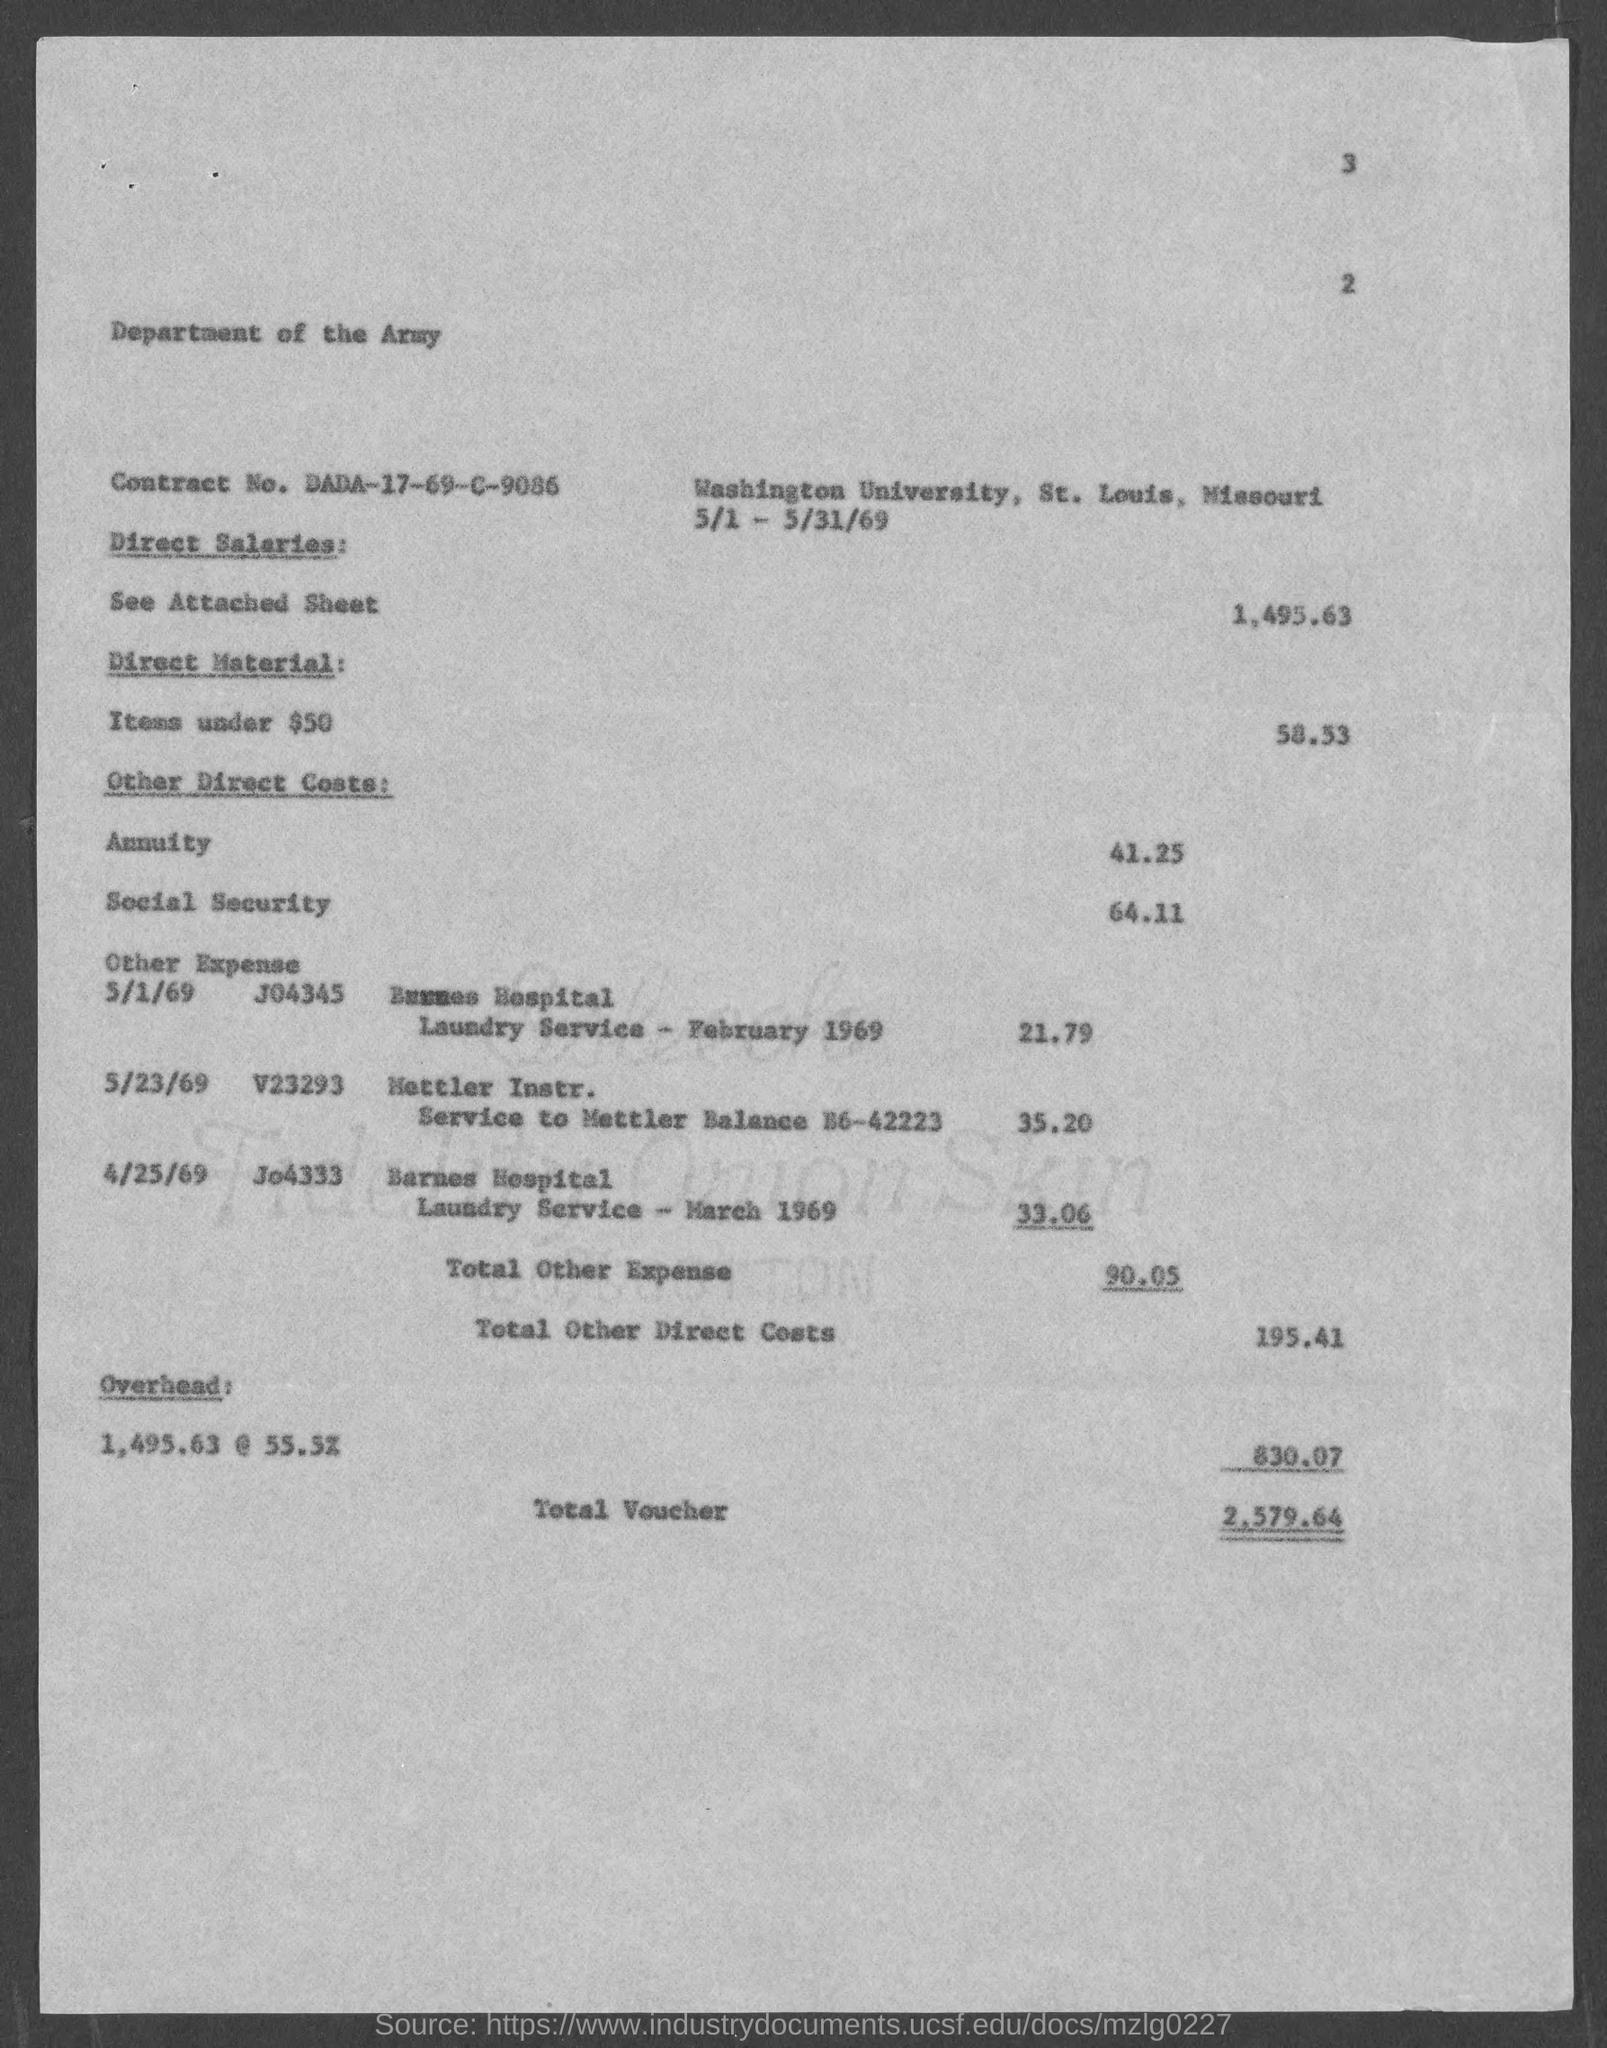What is the Contract No. given in the document?
Offer a terse response. DADA-17-69-C-9086. What is the direct salaries cost mentioned in the document?
Your answer should be compact. 1,495.63. What is the Direct material cost (Items under $50) given in the document?
Your answer should be compact. 58.53. What is the social security cost mentioned in the document?
Your answer should be compact. 64.11. What is the overhead cost given in the document?
Make the answer very short. 830.07. What is the total voucher amount mentioned in the document?
Ensure brevity in your answer.  2,579.64. 